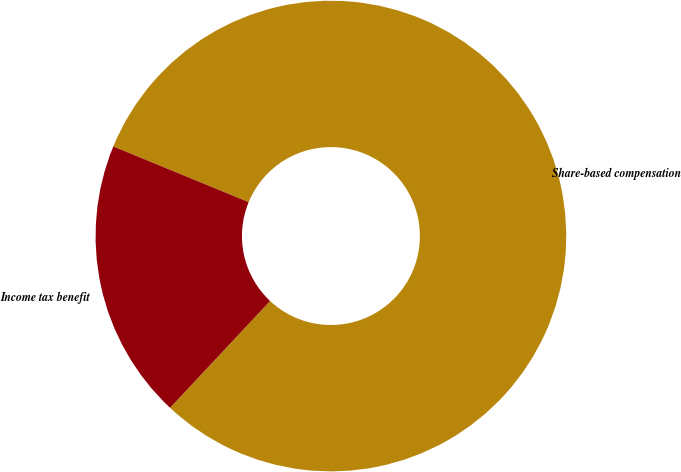<chart> <loc_0><loc_0><loc_500><loc_500><pie_chart><fcel>Share-based compensation<fcel>Income tax benefit<nl><fcel>80.76%<fcel>19.24%<nl></chart> 